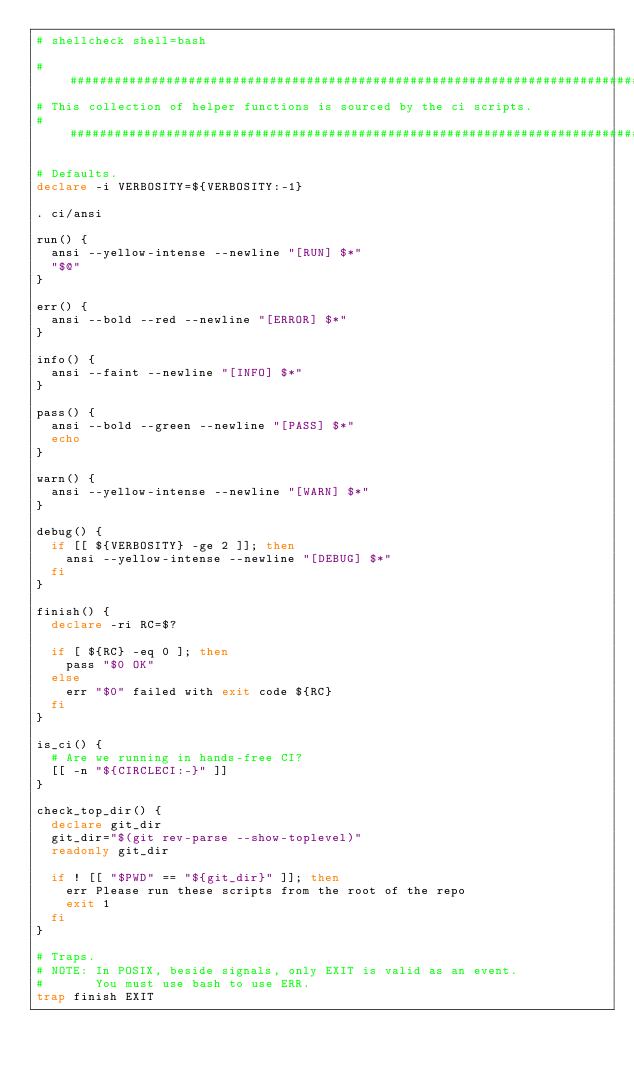Convert code to text. <code><loc_0><loc_0><loc_500><loc_500><_Bash_># shellcheck shell=bash

################################################################################
# This collection of helper functions is sourced by the ci scripts.
################################################################################

# Defaults.
declare -i VERBOSITY=${VERBOSITY:-1}

. ci/ansi

run() {
  ansi --yellow-intense --newline "[RUN] $*"
  "$@"
}

err() {
  ansi --bold --red --newline "[ERROR] $*"
}

info() {
  ansi --faint --newline "[INFO] $*"
}

pass() {
  ansi --bold --green --newline "[PASS] $*"
  echo
}

warn() {
  ansi --yellow-intense --newline "[WARN] $*"
}

debug() {
  if [[ ${VERBOSITY} -ge 2 ]]; then
    ansi --yellow-intense --newline "[DEBUG] $*"
  fi
}

finish() {
  declare -ri RC=$?

  if [ ${RC} -eq 0 ]; then
    pass "$0 OK"
  else
    err "$0" failed with exit code ${RC}
  fi
}

is_ci() {
  # Are we running in hands-free CI?
  [[ -n "${CIRCLECI:-}" ]]
}

check_top_dir() {
  declare git_dir
  git_dir="$(git rev-parse --show-toplevel)"
  readonly git_dir

  if ! [[ "$PWD" == "${git_dir}" ]]; then
    err Please run these scripts from the root of the repo
    exit 1
  fi
}

# Traps.
# NOTE: In POSIX, beside signals, only EXIT is valid as an event.
#       You must use bash to use ERR.
trap finish EXIT
</code> 